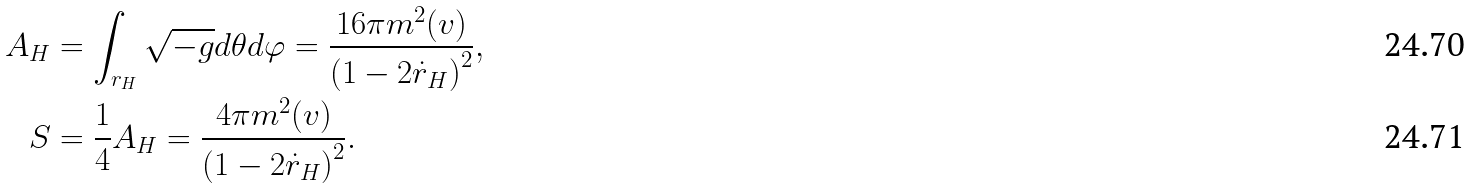<formula> <loc_0><loc_0><loc_500><loc_500>A _ { H } & = \int _ { r _ { H } } \sqrt { - g } d \theta d \varphi = \frac { 1 6 \pi m ^ { 2 } ( v ) } { \left ( 1 - 2 \dot { r } _ { H } \right ) ^ { 2 } } , \\ S & = \frac { 1 } { 4 } A _ { H } = \frac { 4 \pi m ^ { 2 } ( v ) } { \left ( 1 - 2 \dot { r } _ { H } \right ) ^ { 2 } } .</formula> 